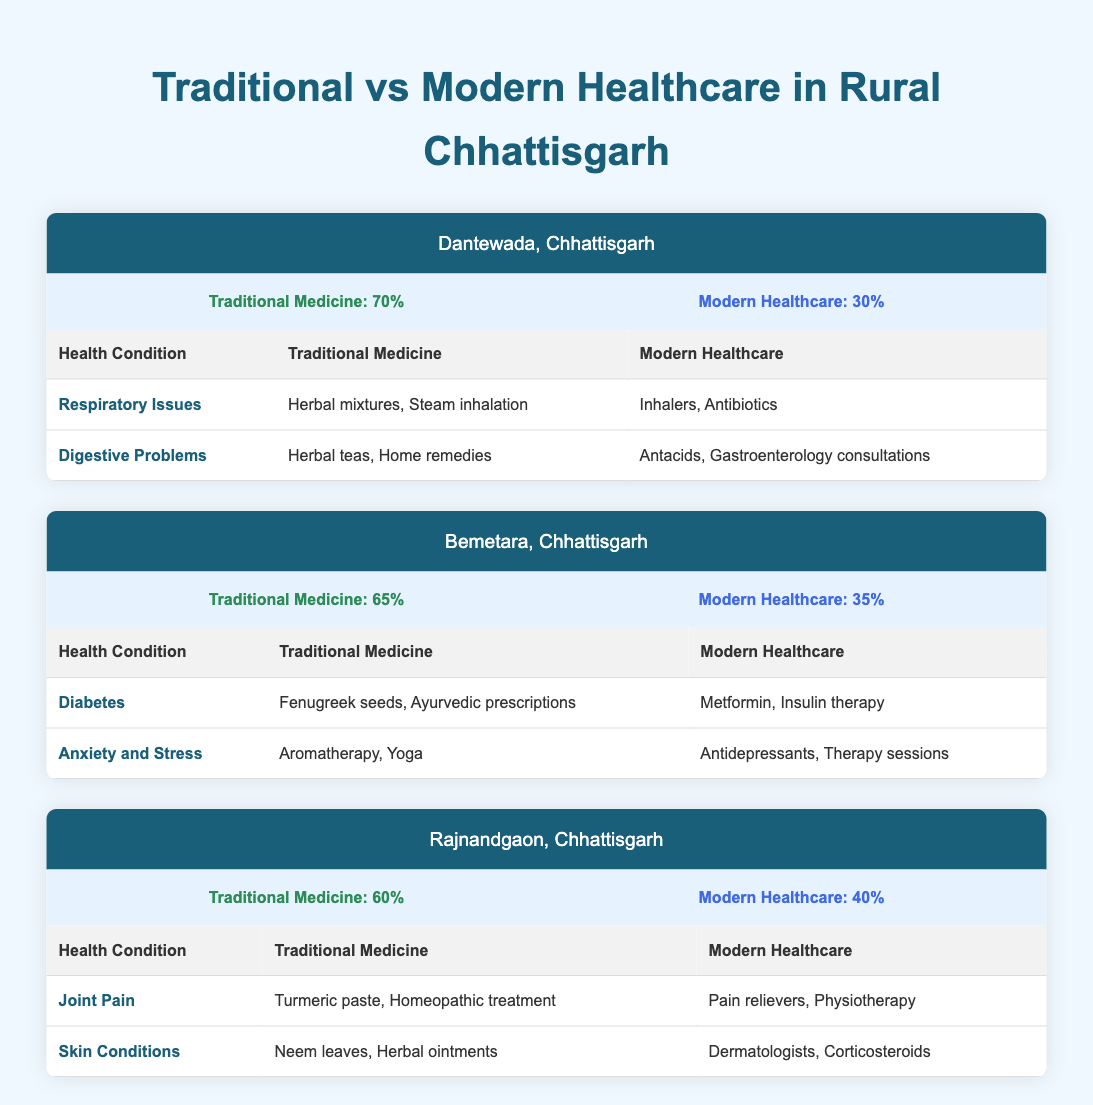What is the traditional medicine usage percentage in Dantewada? The table indicates that in Dantewada, Chhattisgarh, the traditional medicine usage percentage is listed as 70%. This value can be found directly in the usage statistics for this region.
Answer: 70% What health condition in Bemetara is treated with aromatherapy? According to the table, anxiety and stress in Bemetara are treated with aromatherapy as part of traditional medicine. This is explicitly stated in the health conditions listed for this region.
Answer: Anxiety and Stress Which region has the highest percentage of modern healthcare usage? By examining the table, we see that Rajnandgaon has a modern healthcare usage percentage of 40%, which is the highest compared to 30% in Dantewada and 35% in Bemetara. Thus, Rajnandgaon is identified as having the highest modern healthcare usage.
Answer: Rajnandgaon What is the average percentage of traditional medicine usage across all three regions? To find the average, we sum the traditional medicine usage percentages from all regions: 70% (Dantewada) + 65% (Bemetara) + 60% (Rajnandgaon) = 195%. Then, we divide by the number of regions, which is 3: 195% / 3 = 65%. Therefore, the average traditional medicine usage percentage is 65%.
Answer: 65% Is it true that all three regions use traditional medicine for respiratory issues? Looking at the table, respiratory issues are listed only for Dantewada as a health condition treated with traditional medicine. Hence, it is false to state that all regions use traditional medicine for this condition.
Answer: No What are the modern healthcare treatments for digestive problems in Dantewada? The table specifies that the modern healthcare treatments for digestive problems in Dantewada include antacids and gastroenterology consultations. This information comes directly from the health conditions listed under this region.
Answer: Antacids, Gastroenterology consultations In which region is turmeric paste used for treating joint pain? The table indicates that turmeric paste is used for treating joint pain in Rajnandgaon. This is explicitly stated in the health conditions for this region.
Answer: Rajnandgaon How does the traditional medicine usage in Bemetara compare to that in Rajnandgaon? The traditional medicine usage in Bemetara is 65%, and in Rajnandgaon, it is 60%. Thus, Bemetara has a higher traditional medicine usage than Rajnandgaon by 5%. This comparison can be easily drawn from the percentages in the table.
Answer: Bemetara is 5% higher 